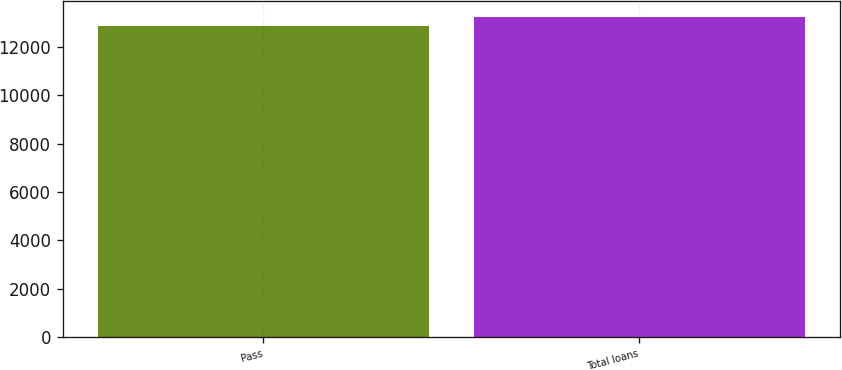Convert chart. <chart><loc_0><loc_0><loc_500><loc_500><bar_chart><fcel>Pass<fcel>Total loans<nl><fcel>12893<fcel>13263<nl></chart> 